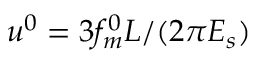<formula> <loc_0><loc_0><loc_500><loc_500>u ^ { 0 } = 3 f _ { m } ^ { 0 } L / ( 2 \pi E _ { s } )</formula> 